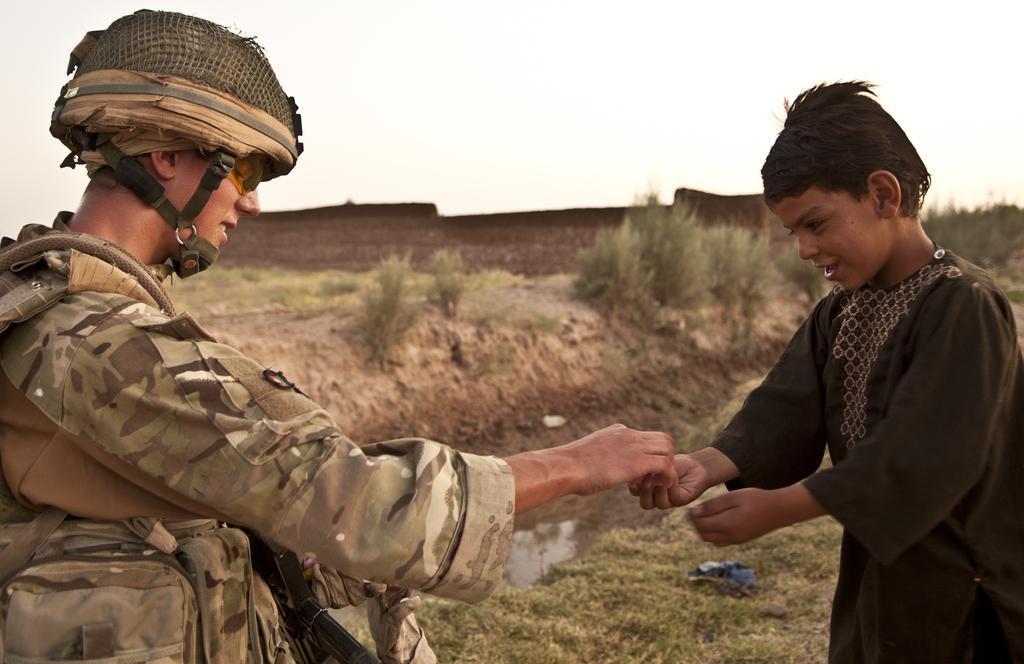Could you give a brief overview of what you see in this image? In this image, there are a few people. We can see the ground with some objects. We can also see some grass, water and plants. We can also see the wall and the sky. 